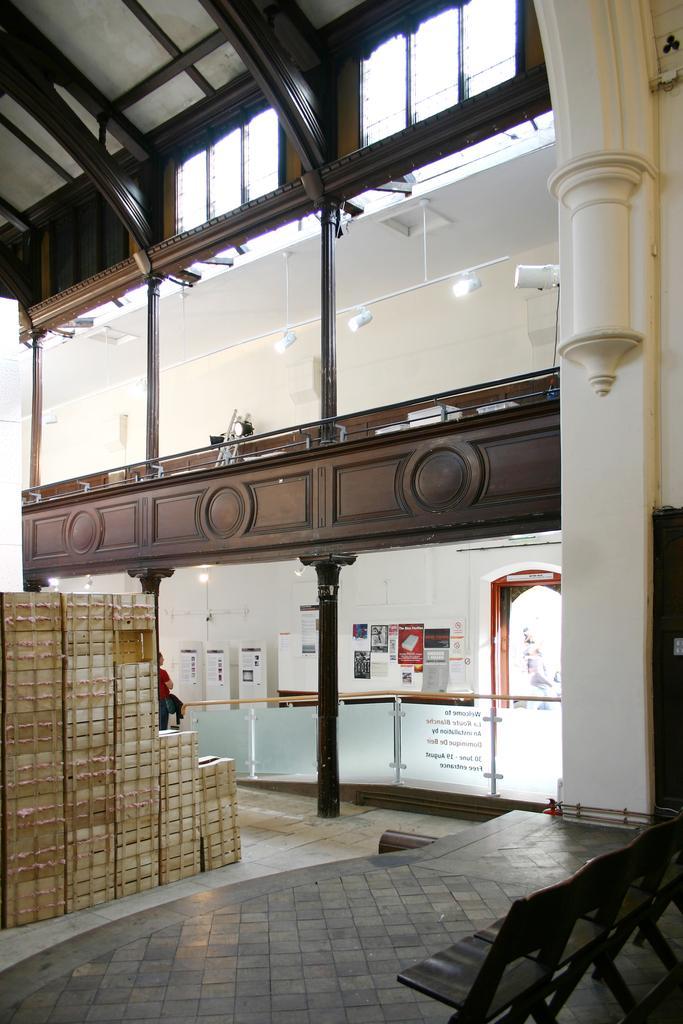Describe this image in one or two sentences. Here we can see boxes, chairs, poles, lights, glasses, and posters. This is floor. In the background we can see wall. 